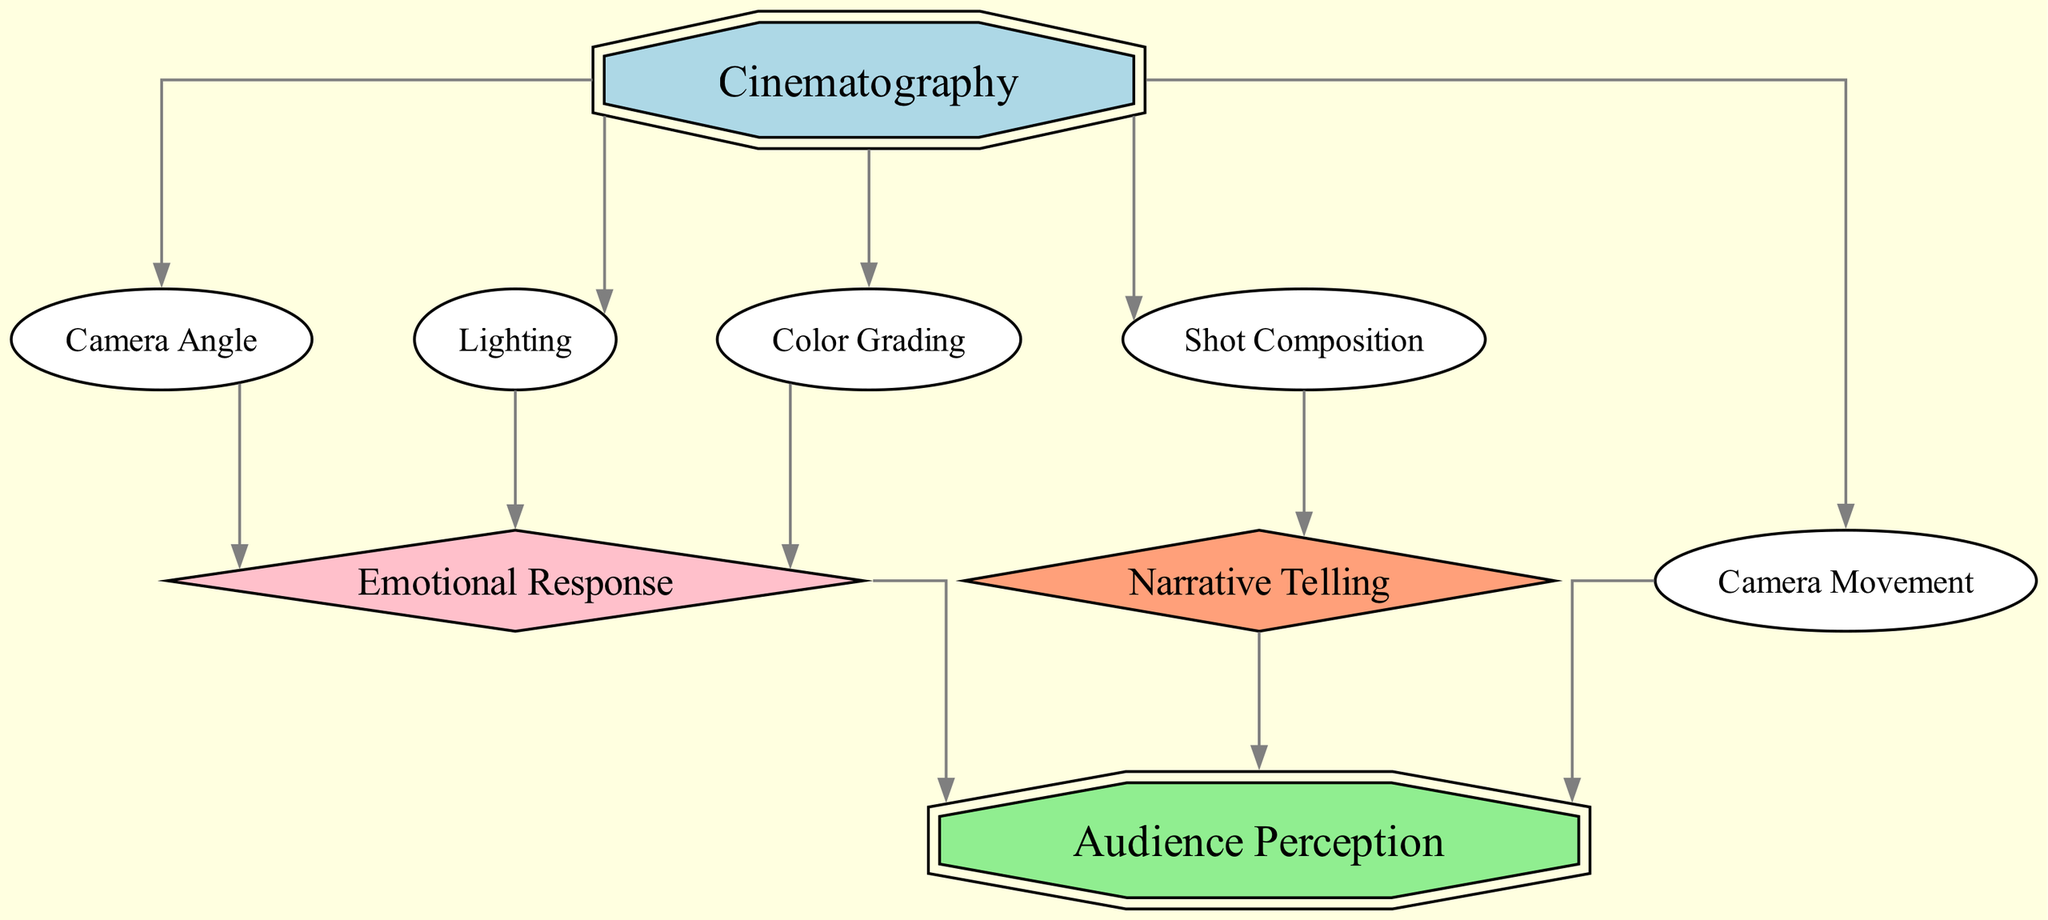What is the total number of nodes in the diagram? The diagram lists the nodes: Cinematography, Camera Angle, Lighting, Color Grading, Shot Composition, Movement, Emotional Response, Narrative Telling, and Audience Perception. Counting these gives a total of 9 nodes.
Answer: 9 What is the relationship between Cinematography and Camera Angle? The diagram indicates a direct edge (relationship) from Cinematography to Camera Angle, showing that Cinematography influences the Camera Angle.
Answer: Influences Which node has the most direct connections? By examining the edges, Cinematography connects to five nodes: Camera Angle, Lighting, Color Grading, Shot Composition, and Movement. It has the highest number of direct connections.
Answer: Cinematography How many edges are directed towards Audience Perception? The edges show that three nodes—Movement, Emotional Response, and Narrative Telling—directly connect to Audience Perception, indicating different influences on audience perception.
Answer: 3 What impact does Lighting have on audience reaction? Lighting connects directly to Emotional Response, which then connects to Audience Perception, indicating that Lighting indirectly impacts audience perception through Emotional Response.
Answer: Indirect impact What is the flow of influence from Shot Composition to Audience Perception? Shot Composition connects to Narrative Telling, and then Narrative Telling connects to Audience Perception, showing that Shot Composition influences Audience Perception through Narrative Telling. The sequence demonstrates this flow of influence.
Answer: Through Narrative Telling In terms of node types, how many nodes are classified as diamonds? The diagram categorizes Emotional Response and Narrative Telling as diamonds, meaning they represent decision points or critical outcomes. Counting these gives a total of 2 diamond-shaped nodes.
Answer: 2 What specific role does Camera Movement play regarding Audience Perception? Camera Movement has a direct edge connecting it to Audience Perception, meaning Camera Movement directly influences how the audience perceives the film.
Answer: Direct influence Does Color Grading have a direct or indirect effect on Audience Perception? Color Grading connects directly to Emotional Response, which then leads to Audience Perception, indicating Color Grading has an indirect effect on Audience Perception.
Answer: Indirect effect 